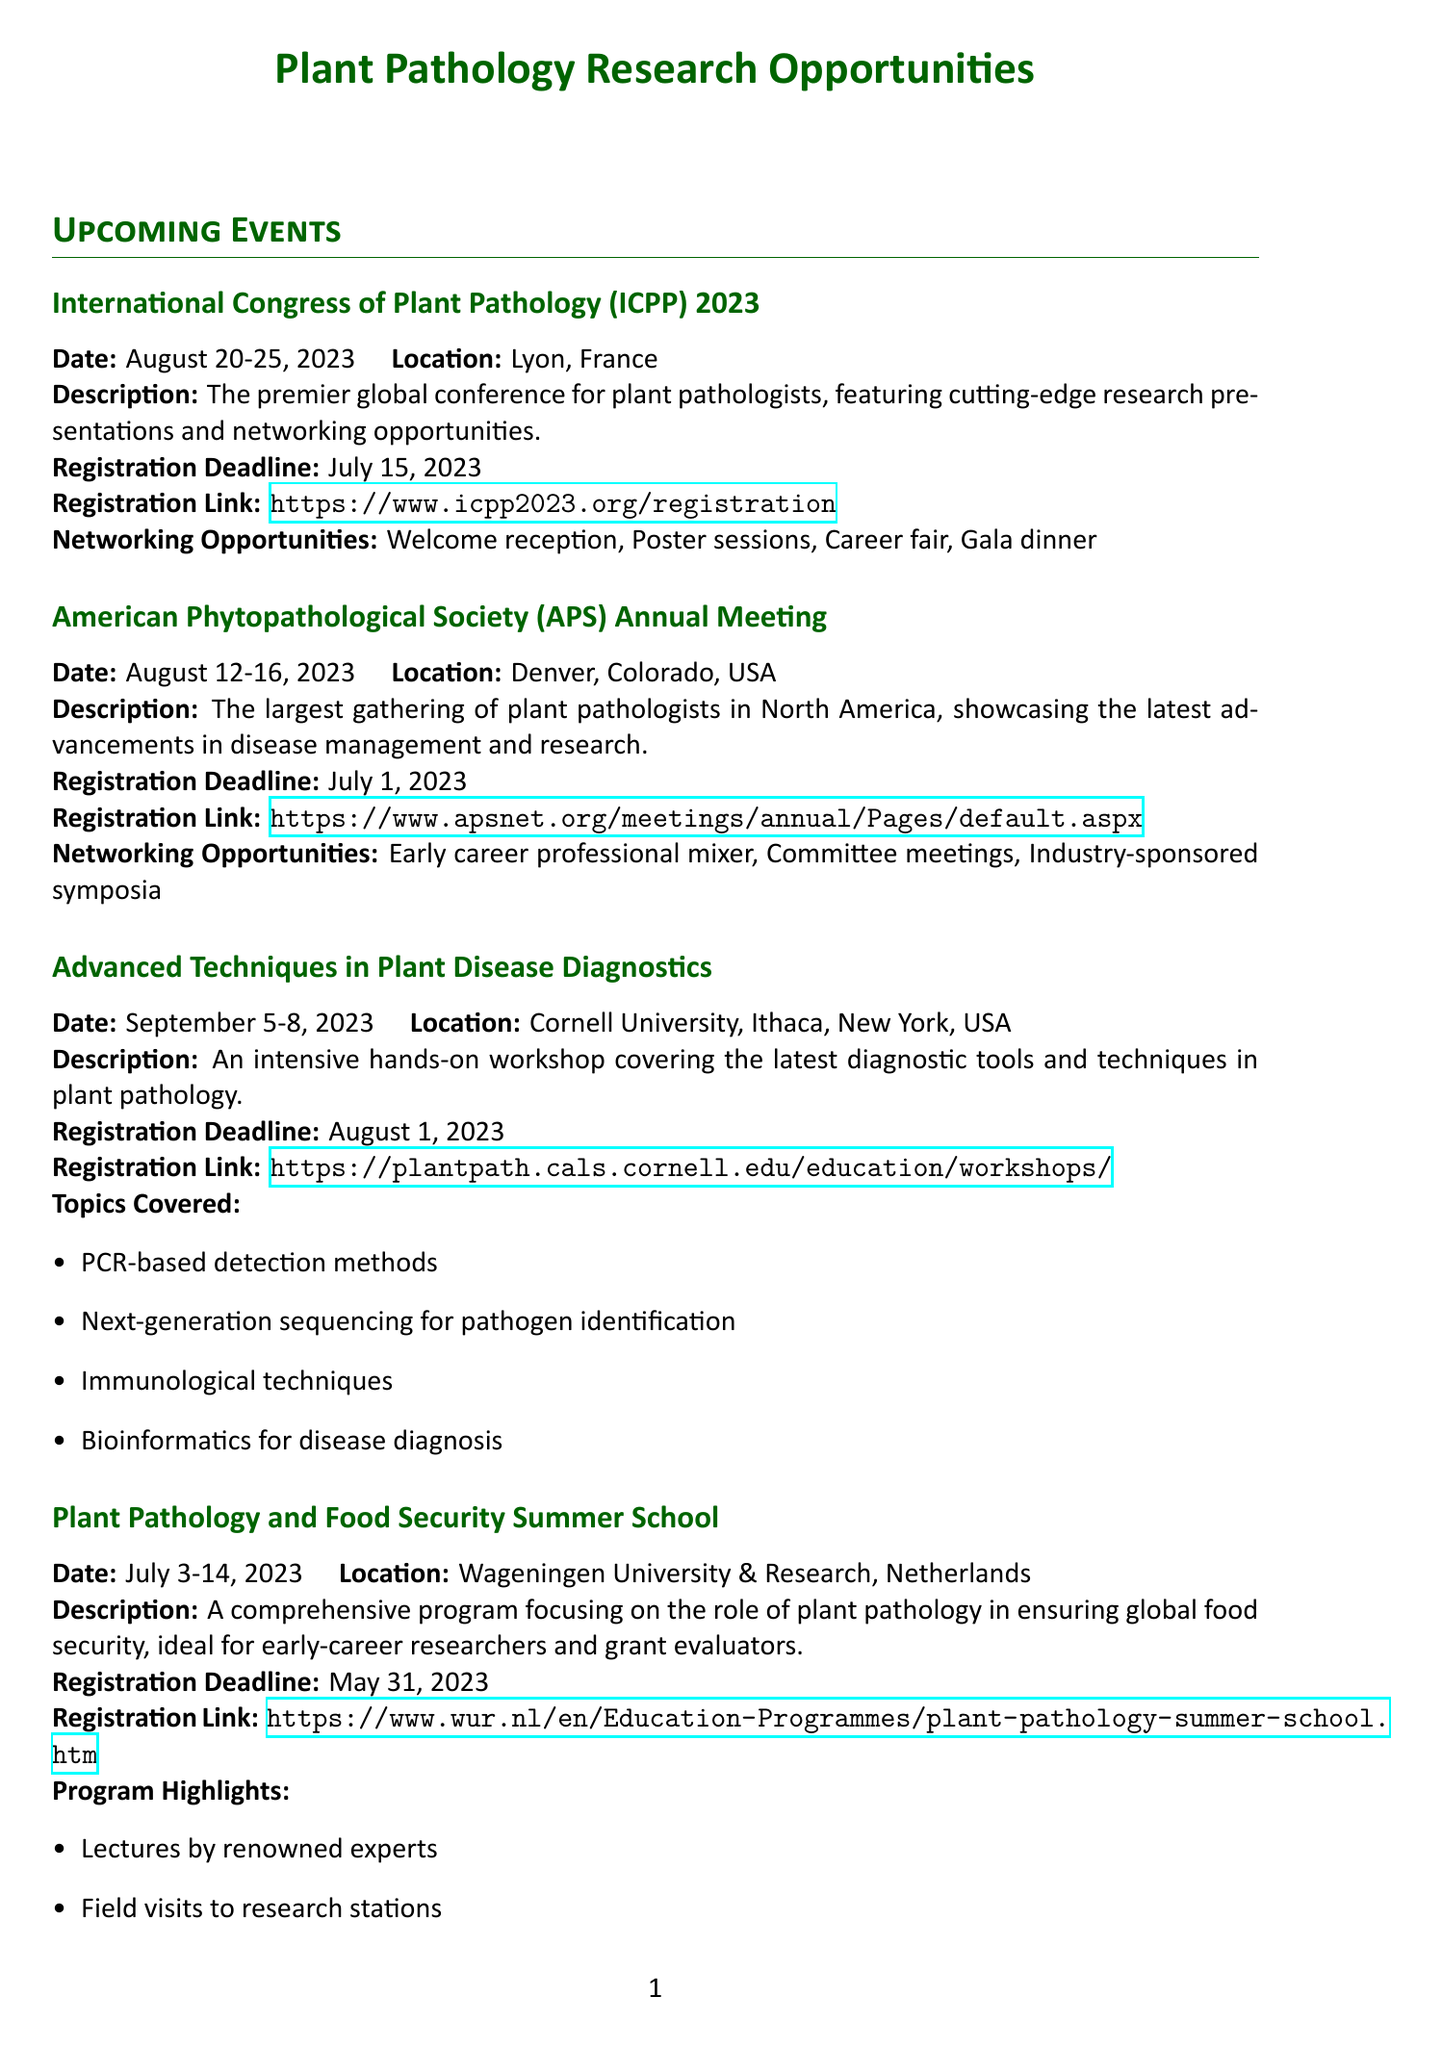What are the dates for the ICPP 2023? The dates for the ICPP 2023 are mentioned under the event details, specifically for the International Congress of Plant Pathology.
Answer: August 20-25, 2023 Where is the APS Annual Meeting taking place? The location of the APS Annual Meeting is specified in the event details.
Answer: Denver, Colorado, USA What is the registration deadline for the Advanced Techniques workshop? The registration deadline for the workshop is explicitly provided in the workshop details.
Answer: August 1, 2023 What topics are covered in the Advanced Techniques workshop? The topics are outlined in the workshop section, giving a brief overview of what will be taught.
Answer: PCR-based detection methods, Next-generation sequencing for pathogen identification, Immunological techniques, Bioinformatics for disease diagnosis What special sessions will be available at the EFPP Conference? The special sessions are listed under the EFPP Conference section, highlighting important activities taking place at the event.
Answer: Grant writing workshop for early-career researchers, Panel discussion on funding priorities in plant pathology, Networking lunch with funding agency representatives What is the focus area of the USDA-NIFA grant? The focus area is defined in the funding opportunities section under the USDA-NIFA grant details.
Answer: Plant Health and Production and Plant Products When is the application deadline for the ERC Consolidator Grants? The application deadline is mentioned for the ERC Consolidator Grants in the funding opportunities section.
Answer: February 2024 (exact date TBA) Which event includes networking opportunities for early-career professionals? The networking opportunities for early-career professionals are specifically highlighted in the relevant event details.
Answer: APS Annual Meeting What program highlights are included in the Plant Pathology and Food Security Summer School? The program highlights are listed comprehensively under the summer school section, showcasing key activities.
Answer: Lectures by renowned experts, Field visits to research stations, Group projects on grant proposal evaluation, Networking events with industry professionals 